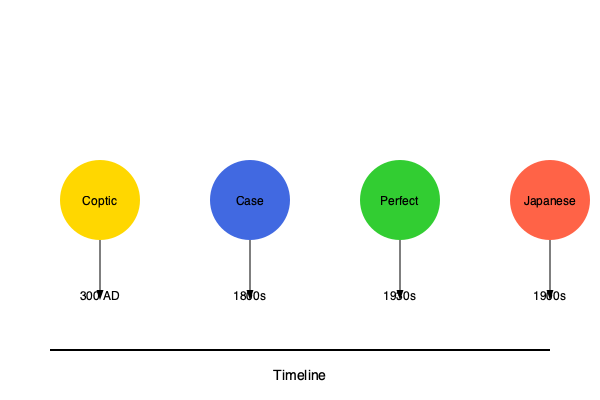Based on the timeline of bookbinding techniques shown in the image, which method is considered the oldest and what significant feature distinguishes it from later techniques? To answer this question, let's analyze the information provided in the graphic:

1. The image shows a timeline of four different bookbinding techniques: Coptic, Case, Perfect, and Japanese.

2. Each technique is represented by a colored circle and has a corresponding date below it on the timeline.

3. The dates for each technique are:
   - Coptic: 300 AD
   - Case: 1800s
   - Perfect: 1930s
   - Japanese: 1900s

4. Comparing these dates, we can see that the Coptic binding technique is the oldest, dating back to 300 AD.

5. The significant feature that distinguishes Coptic binding from later techniques is its exposed spine. In Coptic binding, the stitching that holds the pages together is visible on the outside of the spine, creating a decorative and functional element.

6. Later techniques, such as case binding (1800s), typically enclose the stitching within a hardcover, hiding the spine construction. Perfect binding (1930s) uses adhesive instead of stitching, and Japanese binding (1900s) has a unique side-stitch method.

7. The exposed spine of Coptic binding allows the book to lay completely flat when opened, which is a practical feature that many later binding methods struggle to achieve.
Answer: Coptic binding (300 AD); exposed spine 